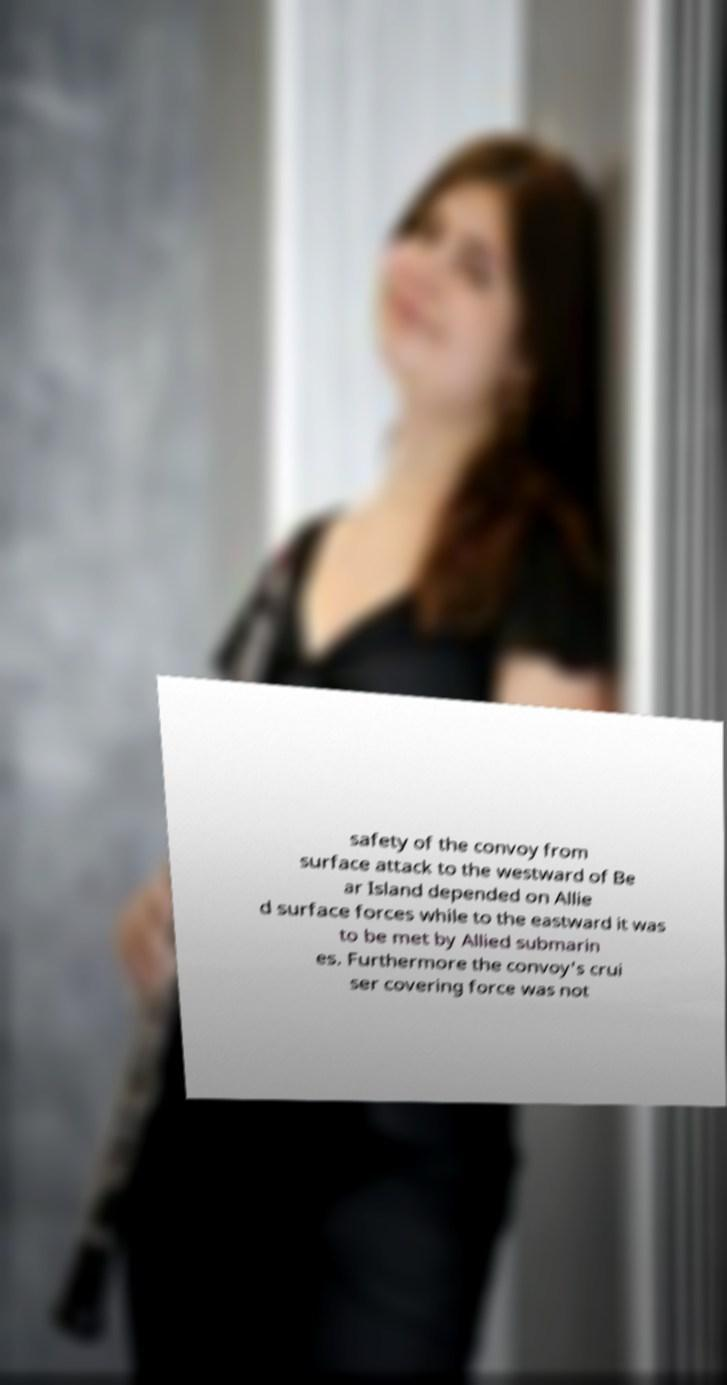Can you read and provide the text displayed in the image?This photo seems to have some interesting text. Can you extract and type it out for me? safety of the convoy from surface attack to the westward of Be ar Island depended on Allie d surface forces while to the eastward it was to be met by Allied submarin es. Furthermore the convoy's crui ser covering force was not 